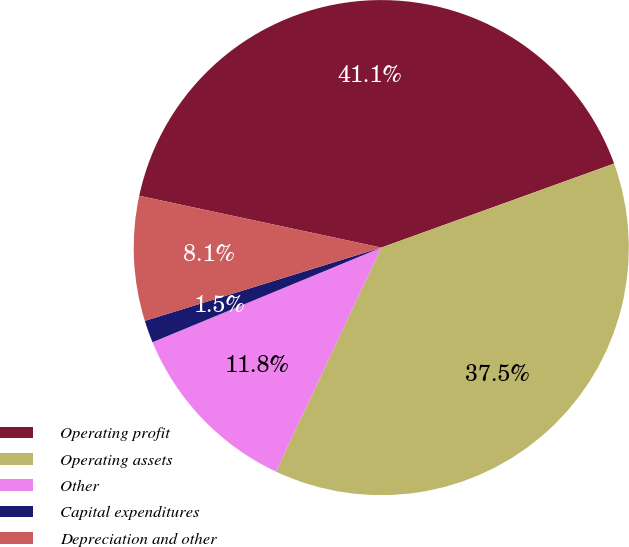<chart> <loc_0><loc_0><loc_500><loc_500><pie_chart><fcel>Operating profit<fcel>Operating assets<fcel>Other<fcel>Capital expenditures<fcel>Depreciation and other<nl><fcel>41.13%<fcel>37.51%<fcel>11.76%<fcel>1.46%<fcel>8.14%<nl></chart> 